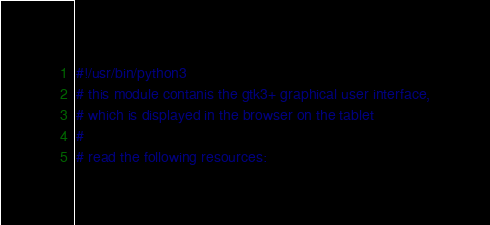Convert code to text. <code><loc_0><loc_0><loc_500><loc_500><_Python_>#!/usr/bin/python3
# this module contanis the gtk3+ graphical user interface,
# which is displayed in the browser on the tablet
#
# read the following resources:</code> 